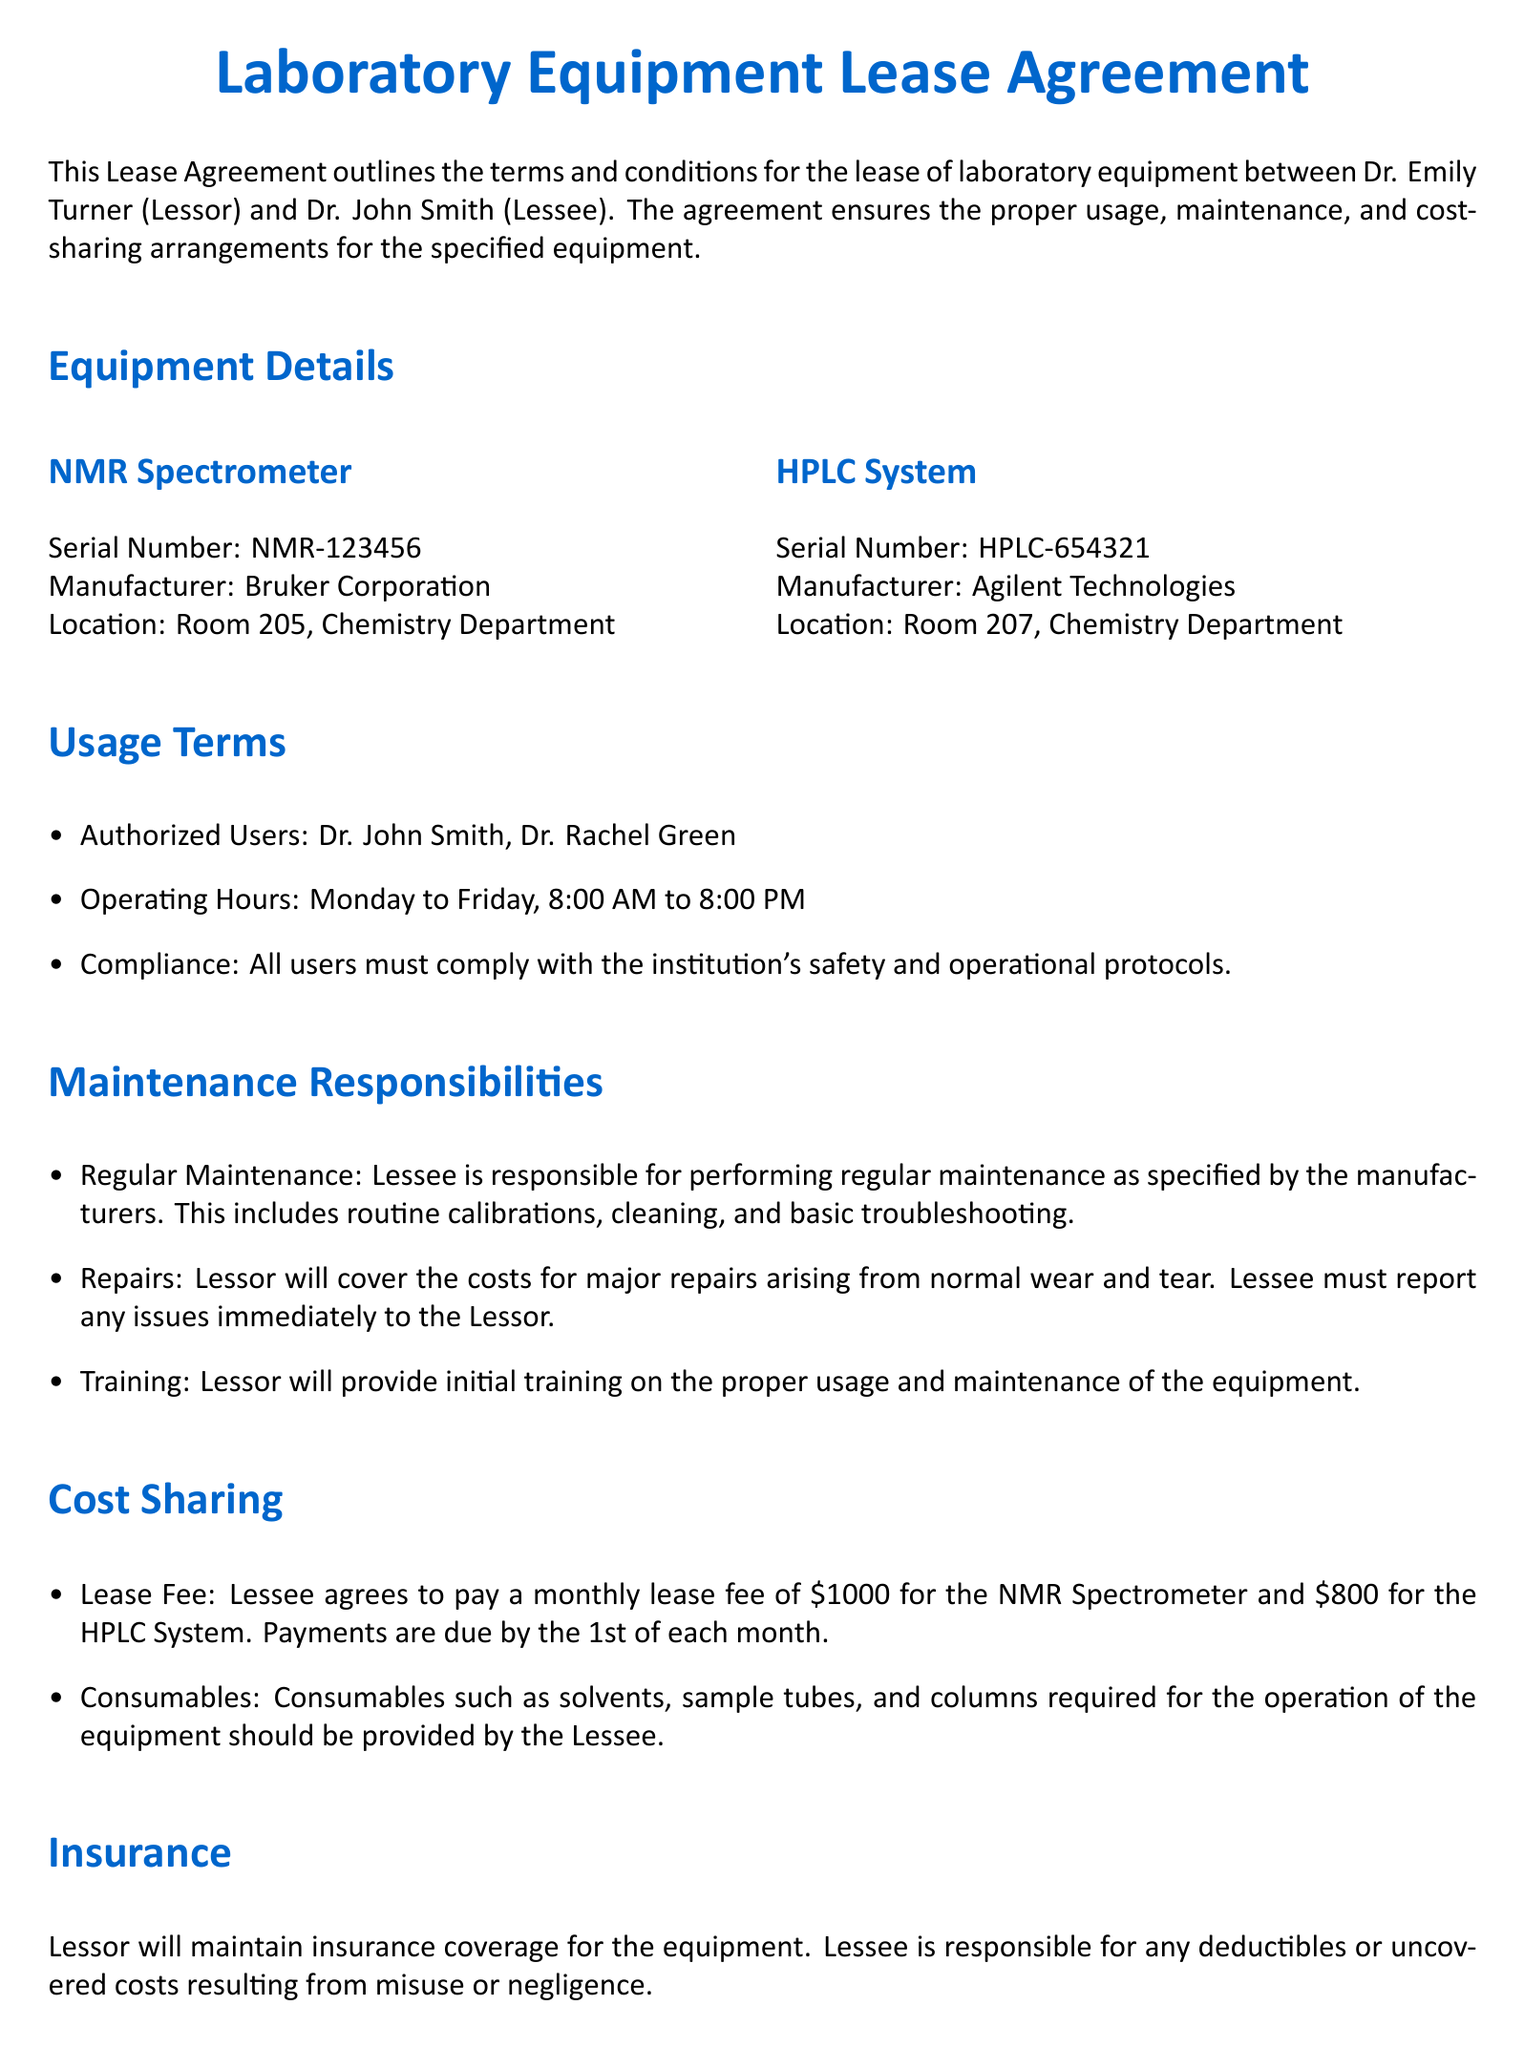what is the lease fee for the NMR Spectrometer? The lease fee is stated in the Cost Sharing section of the document as \$1000.
Answer: \$1000 who is responsible for regular maintenance? The Maintenance Responsibilities section specifies that the Lessee is responsible for performing regular maintenance.
Answer: Lessee what are the operating hours for equipment usage? The usage terms detail the operating hours as Monday to Friday, 8:00 AM to 8:00 PM.
Answer: Monday to Friday, 8:00 AM to 8:00 PM how much is the monthly lease fee for the HPLC System? The Cost Sharing section indicates that the lease fee for the HPLC System is \$800.
Answer: \$800 who provides training on equipment usage? The Maintenance Responsibilities section states that the Lessor will provide initial training on proper usage and maintenance.
Answer: Lessor what is the notice period for termination of the agreement? The Termination section mentions that a 30-day written notice is required to terminate the agreement.
Answer: 30-day what should the Lessee do if there are issues with the equipment? The Maintenance Responsibilities section requires the Lessee to report any issues immediately to the Lessor.
Answer: Report immediately what happens to the equipment upon termination? The Termination section specifies that the Lessee must return the equipment in good working condition, allowing for normal wear and tear.
Answer: Return in good working condition who is responsible for deductible costs in case of misuse? The Insurance section states that the Lessee is responsible for any deductibles or uncovered costs resulting from misuse or negligence.
Answer: Lessee 